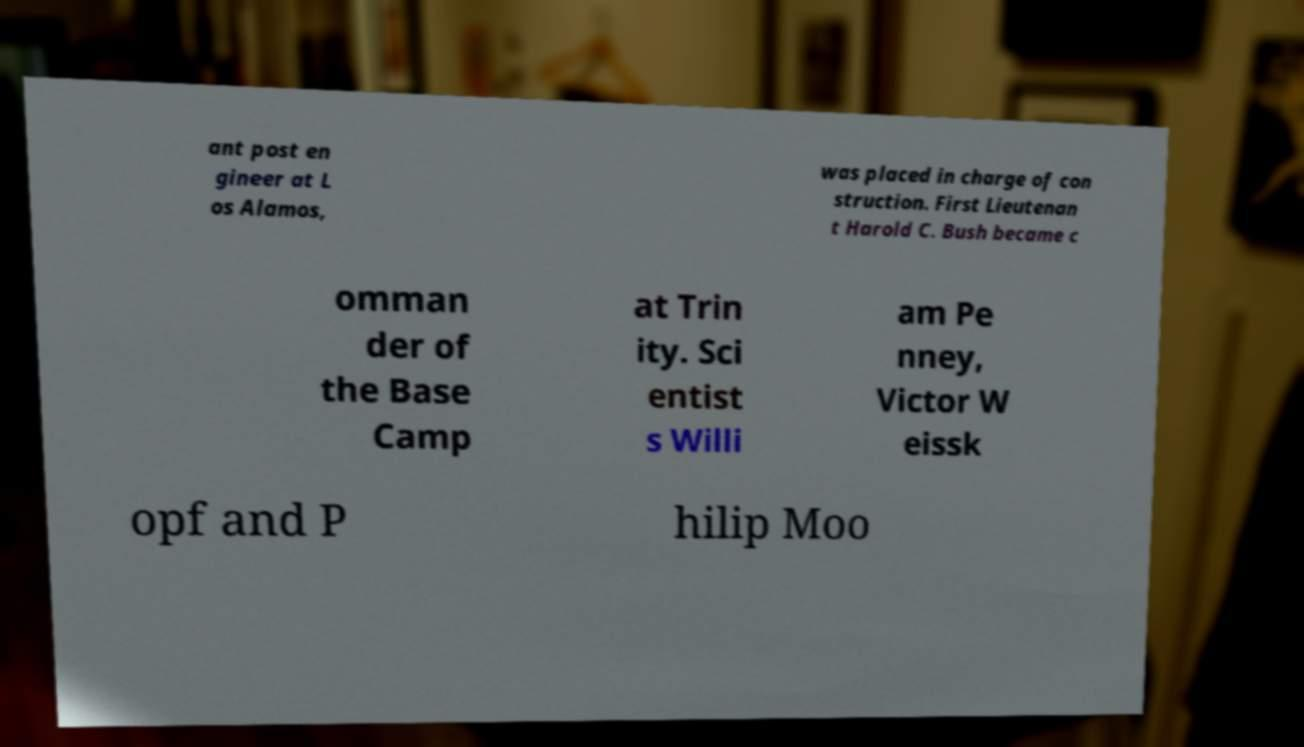Please identify and transcribe the text found in this image. ant post en gineer at L os Alamos, was placed in charge of con struction. First Lieutenan t Harold C. Bush became c omman der of the Base Camp at Trin ity. Sci entist s Willi am Pe nney, Victor W eissk opf and P hilip Moo 